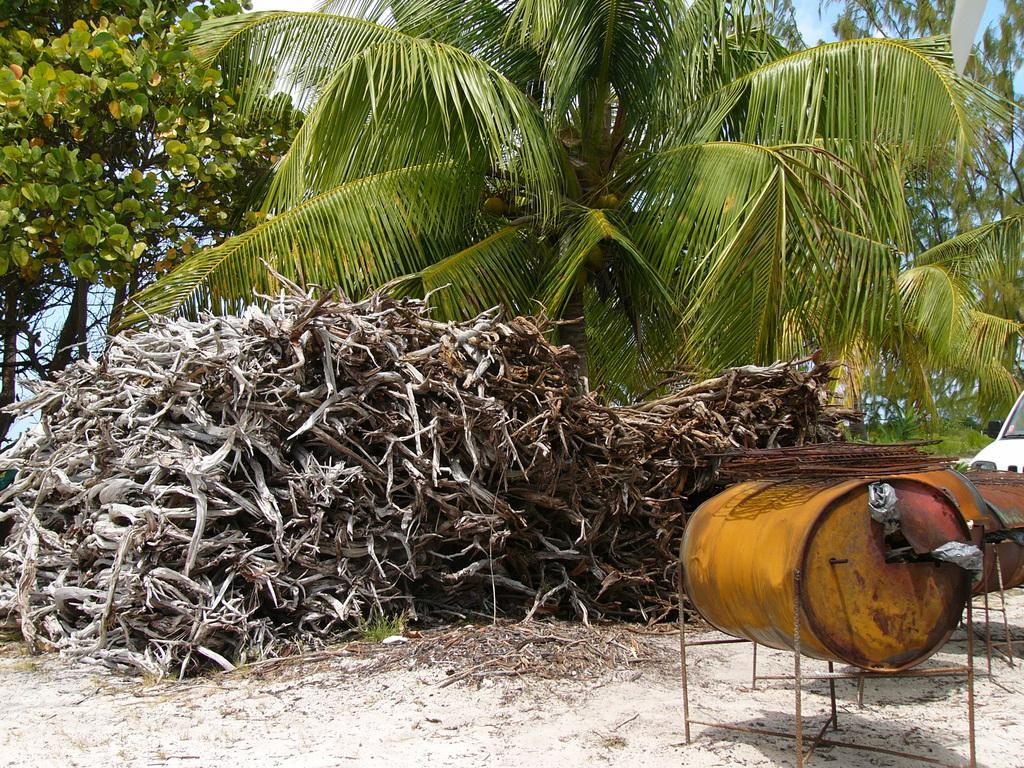What type of plants can be seen in the front side of the image? There are dry plants in the front side of the image. What kind of vegetation is visible in the background of the image? There are green coconut trees in the background of the image. What object can be found on the right side of the image? There is a yellow color drum on the right side of the image. What is the mass of the property in the image? There is no information about the mass of the property in the image, nor is there any reference to a property in the provided facts. 